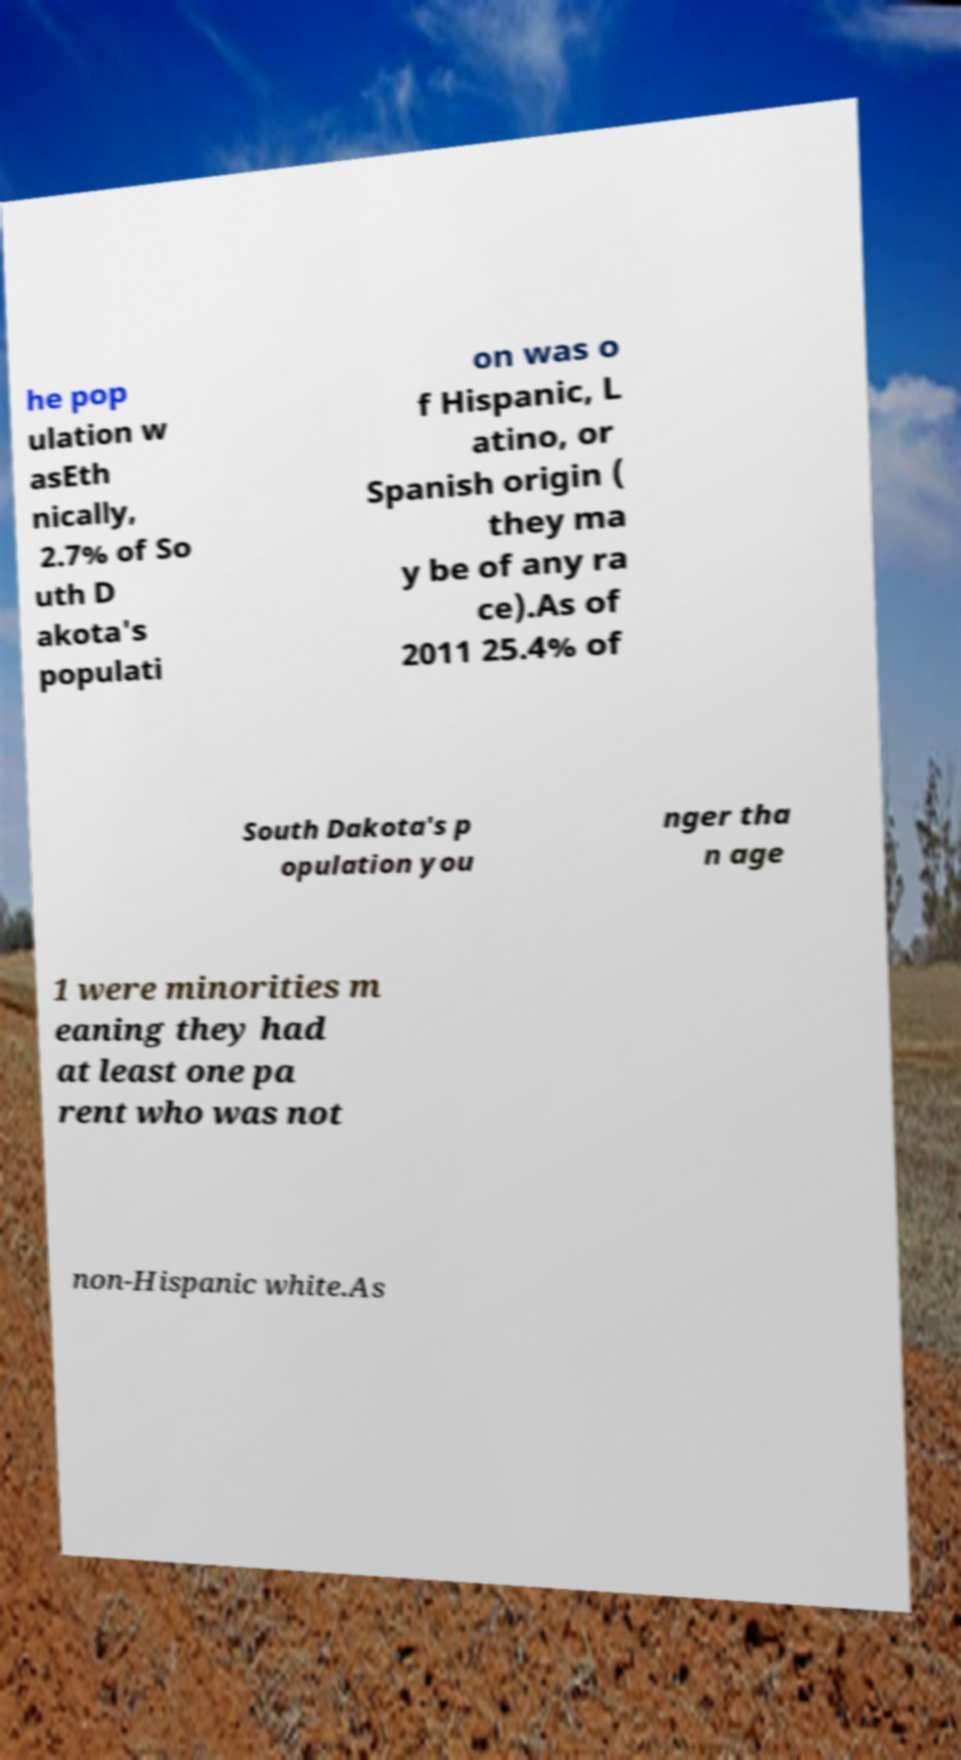There's text embedded in this image that I need extracted. Can you transcribe it verbatim? he pop ulation w asEth nically, 2.7% of So uth D akota's populati on was o f Hispanic, L atino, or Spanish origin ( they ma y be of any ra ce).As of 2011 25.4% of South Dakota's p opulation you nger tha n age 1 were minorities m eaning they had at least one pa rent who was not non-Hispanic white.As 